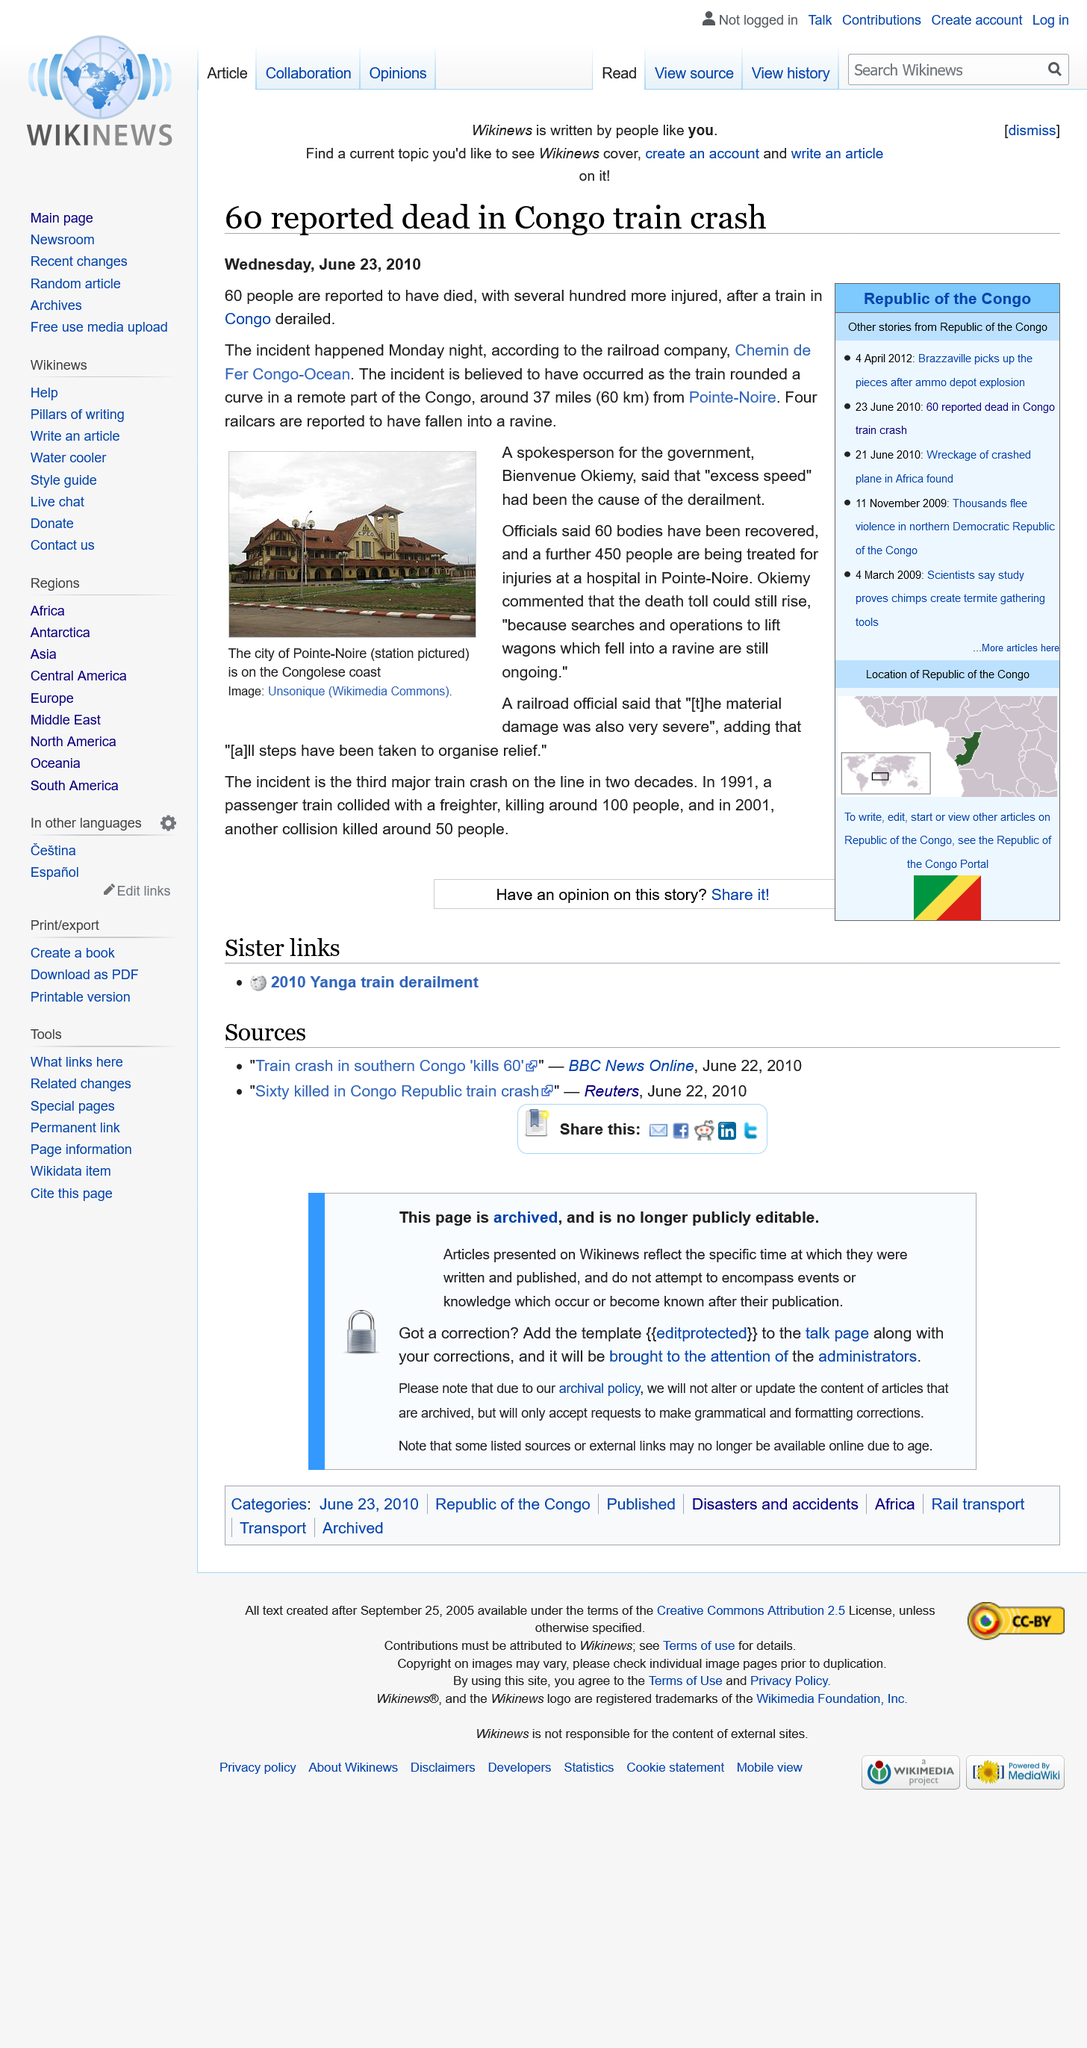Point out several critical features in this image. The article was published on Wednesday June 23rd 2010. Sixty people have reportedly died as a result of a train derailment in the Congo. The image depicts the Pointe-Noire railway station located in the city of Pointe-Noire on the Congolese coast. 